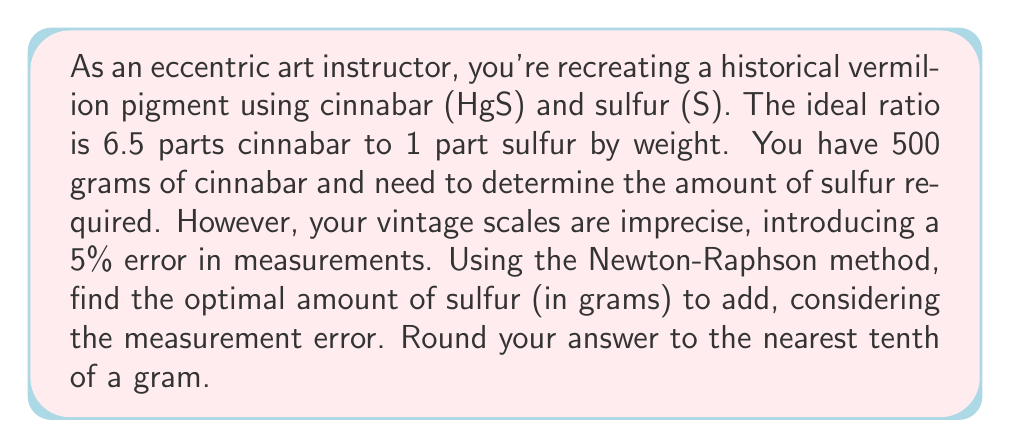Teach me how to tackle this problem. Let's approach this step-by-step:

1) The ideal ratio is 6.5:1 (cinnabar:sulfur). Let x be the amount of sulfur in grams.

2) The equation for the ideal ratio is:
   $$ \frac{500}{x} = 6.5 $$

3) Rearranging this equation:
   $$ f(x) = 500 - 6.5x = 0 $$

4) The derivative of this function is:
   $$ f'(x) = -6.5 $$

5) The Newton-Raphson formula is:
   $$ x_{n+1} = x_n - \frac{f(x_n)}{f'(x_n)} $$

6) Let's start with an initial guess of x₀ = 70 (since 500/6.5 ≈ 76.92):

   $$ x_1 = 70 - \frac{500 - 6.5(70)}{-6.5} = 70 - \frac{45}{-6.5} = 76.92 $$

7) This converges immediately to the exact solution. However, we need to account for the 5% measurement error.

8) The error range for 76.92g of sulfur is:
   $$ 76.92 \pm (76.92 \times 0.05) = 76.92 \pm 3.846 $$

9) This gives us a range of 73.074g to 80.766g of sulfur.

10) The midpoint of this range is:
    $$ \frac{73.074 + 80.766}{2} = 76.92 $$

11) Rounding to the nearest tenth:
    $$ 76.92 \approx 76.9 $$
Answer: 76.9 grams 